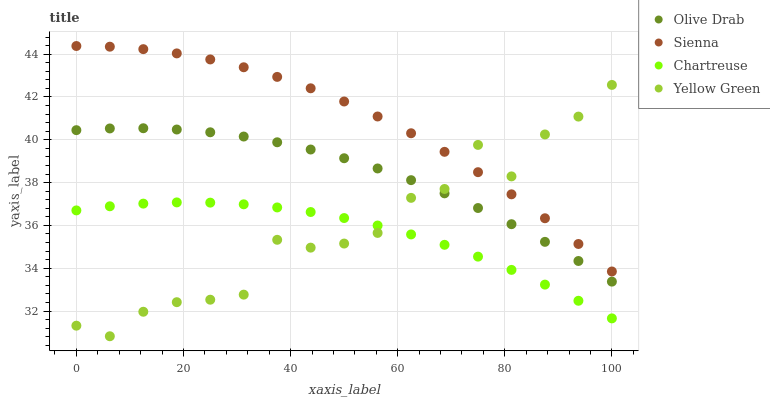Does Chartreuse have the minimum area under the curve?
Answer yes or no. Yes. Does Sienna have the maximum area under the curve?
Answer yes or no. Yes. Does Yellow Green have the minimum area under the curve?
Answer yes or no. No. Does Yellow Green have the maximum area under the curve?
Answer yes or no. No. Is Chartreuse the smoothest?
Answer yes or no. Yes. Is Yellow Green the roughest?
Answer yes or no. Yes. Is Yellow Green the smoothest?
Answer yes or no. No. Is Chartreuse the roughest?
Answer yes or no. No. Does Yellow Green have the lowest value?
Answer yes or no. Yes. Does Chartreuse have the lowest value?
Answer yes or no. No. Does Sienna have the highest value?
Answer yes or no. Yes. Does Yellow Green have the highest value?
Answer yes or no. No. Is Chartreuse less than Olive Drab?
Answer yes or no. Yes. Is Olive Drab greater than Chartreuse?
Answer yes or no. Yes. Does Sienna intersect Yellow Green?
Answer yes or no. Yes. Is Sienna less than Yellow Green?
Answer yes or no. No. Is Sienna greater than Yellow Green?
Answer yes or no. No. Does Chartreuse intersect Olive Drab?
Answer yes or no. No. 